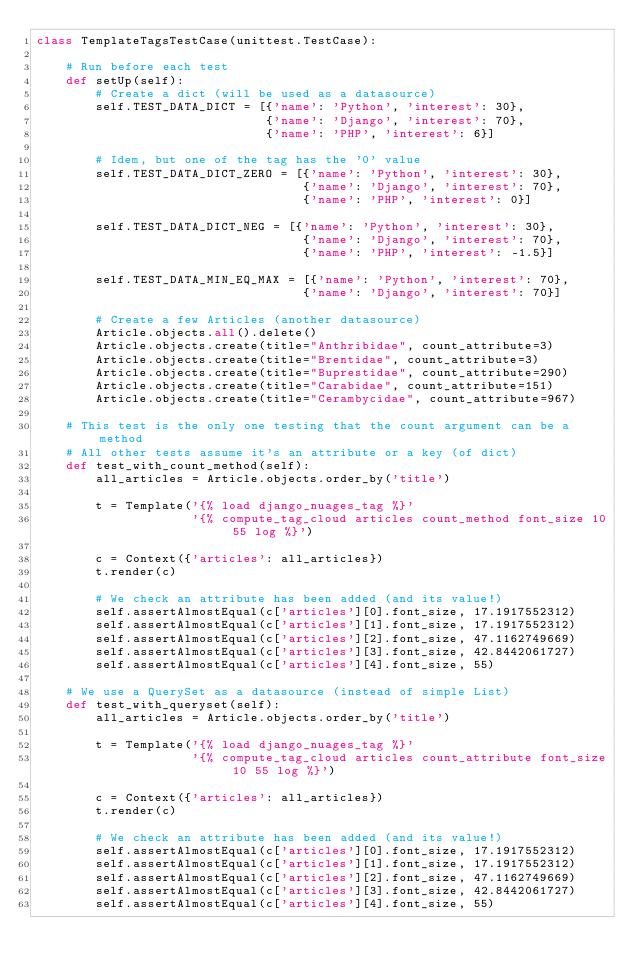<code> <loc_0><loc_0><loc_500><loc_500><_Python_>class TemplateTagsTestCase(unittest.TestCase):
    
    # Run before each test
    def setUp(self):
        # Create a dict (will be used as a datasource)
        self.TEST_DATA_DICT = [{'name': 'Python', 'interest': 30},
                               {'name': 'Django', 'interest': 70},
                               {'name': 'PHP', 'interest': 6}]
        
        # Idem, but one of the tag has the '0' value                       
        self.TEST_DATA_DICT_ZERO = [{'name': 'Python', 'interest': 30},
                                    {'name': 'Django', 'interest': 70},
                                    {'name': 'PHP', 'interest': 0}]
        
        self.TEST_DATA_DICT_NEG = [{'name': 'Python', 'interest': 30},
                                    {'name': 'Django', 'interest': 70},
                                    {'name': 'PHP', 'interest': -1.5}]

        self.TEST_DATA_MIN_EQ_MAX = [{'name': 'Python', 'interest': 70},
                                    {'name': 'Django', 'interest': 70}]                                                                          
        
        # Create a few Articles (another datasource)
        Article.objects.all().delete()
        Article.objects.create(title="Anthribidae", count_attribute=3)
        Article.objects.create(title="Brentidae", count_attribute=3)
        Article.objects.create(title="Buprestidae", count_attribute=290)
        Article.objects.create(title="Carabidae", count_attribute=151)
        Article.objects.create(title="Cerambycidae", count_attribute=967)                                

    # This test is the only one testing that the count argument can be a method
    # All other tests assume it's an attribute or a key (of dict)
    def test_with_count_method(self):
        all_articles = Article.objects.order_by('title')
        
        t = Template('{% load django_nuages_tag %}'
                     '{% compute_tag_cloud articles count_method font_size 10 55 log %}')             
                     
        c = Context({'articles': all_articles})
        t.render(c)
        
        # We check an attribute has been added (and its value!)
        self.assertAlmostEqual(c['articles'][0].font_size, 17.1917552312)
        self.assertAlmostEqual(c['articles'][1].font_size, 17.1917552312)
        self.assertAlmostEqual(c['articles'][2].font_size, 47.1162749669)
        self.assertAlmostEqual(c['articles'][3].font_size, 42.8442061727)
        self.assertAlmostEqual(c['articles'][4].font_size, 55)

    # We use a QuerySet as a datasource (instead of simple List)
    def test_with_queryset(self):
        all_articles = Article.objects.order_by('title')
        
        t = Template('{% load django_nuages_tag %}'
                     '{% compute_tag_cloud articles count_attribute font_size 10 55 log %}')             
                     
        c = Context({'articles': all_articles})
        t.render(c)
        
        # We check an attribute has been added (and its value!)
        self.assertAlmostEqual(c['articles'][0].font_size, 17.1917552312)
        self.assertAlmostEqual(c['articles'][1].font_size, 17.1917552312)
        self.assertAlmostEqual(c['articles'][2].font_size, 47.1162749669)
        self.assertAlmostEqual(c['articles'][3].font_size, 42.8442061727)
        self.assertAlmostEqual(c['articles'][4].font_size, 55)
        
</code> 